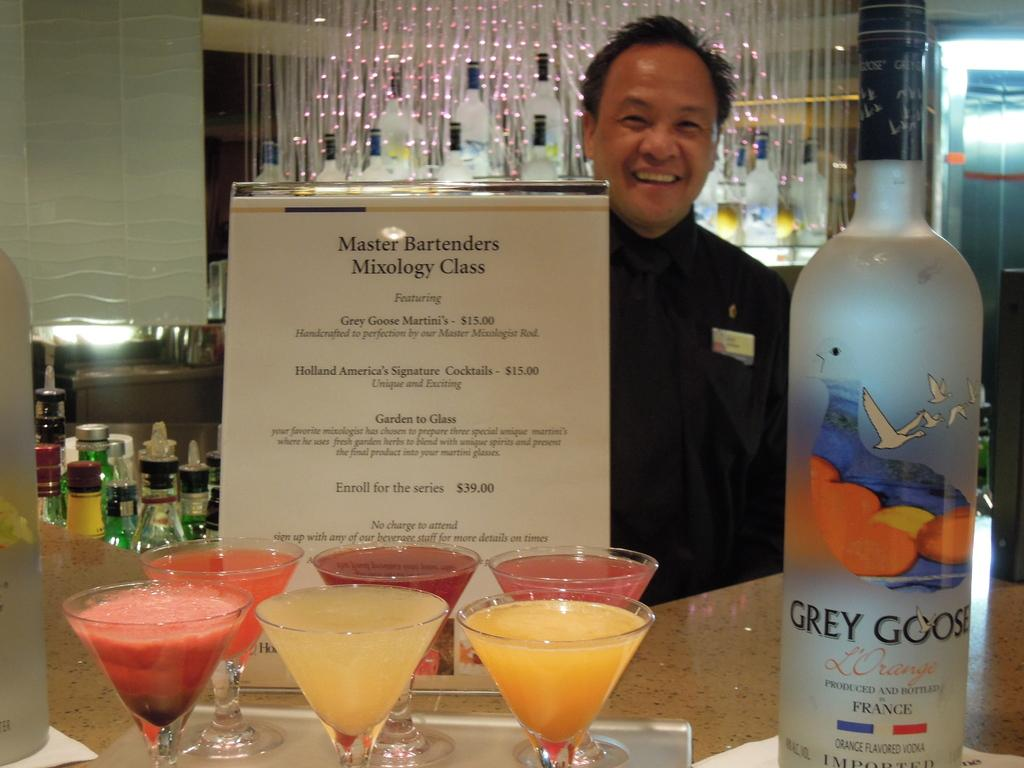<image>
Provide a brief description of the given image. A bartender poses with a bottle of Grey Goose and a menu for the Master Bartender Mixology Class featuring Grey Goose Martini's for $15.00 as well as other drinks. 